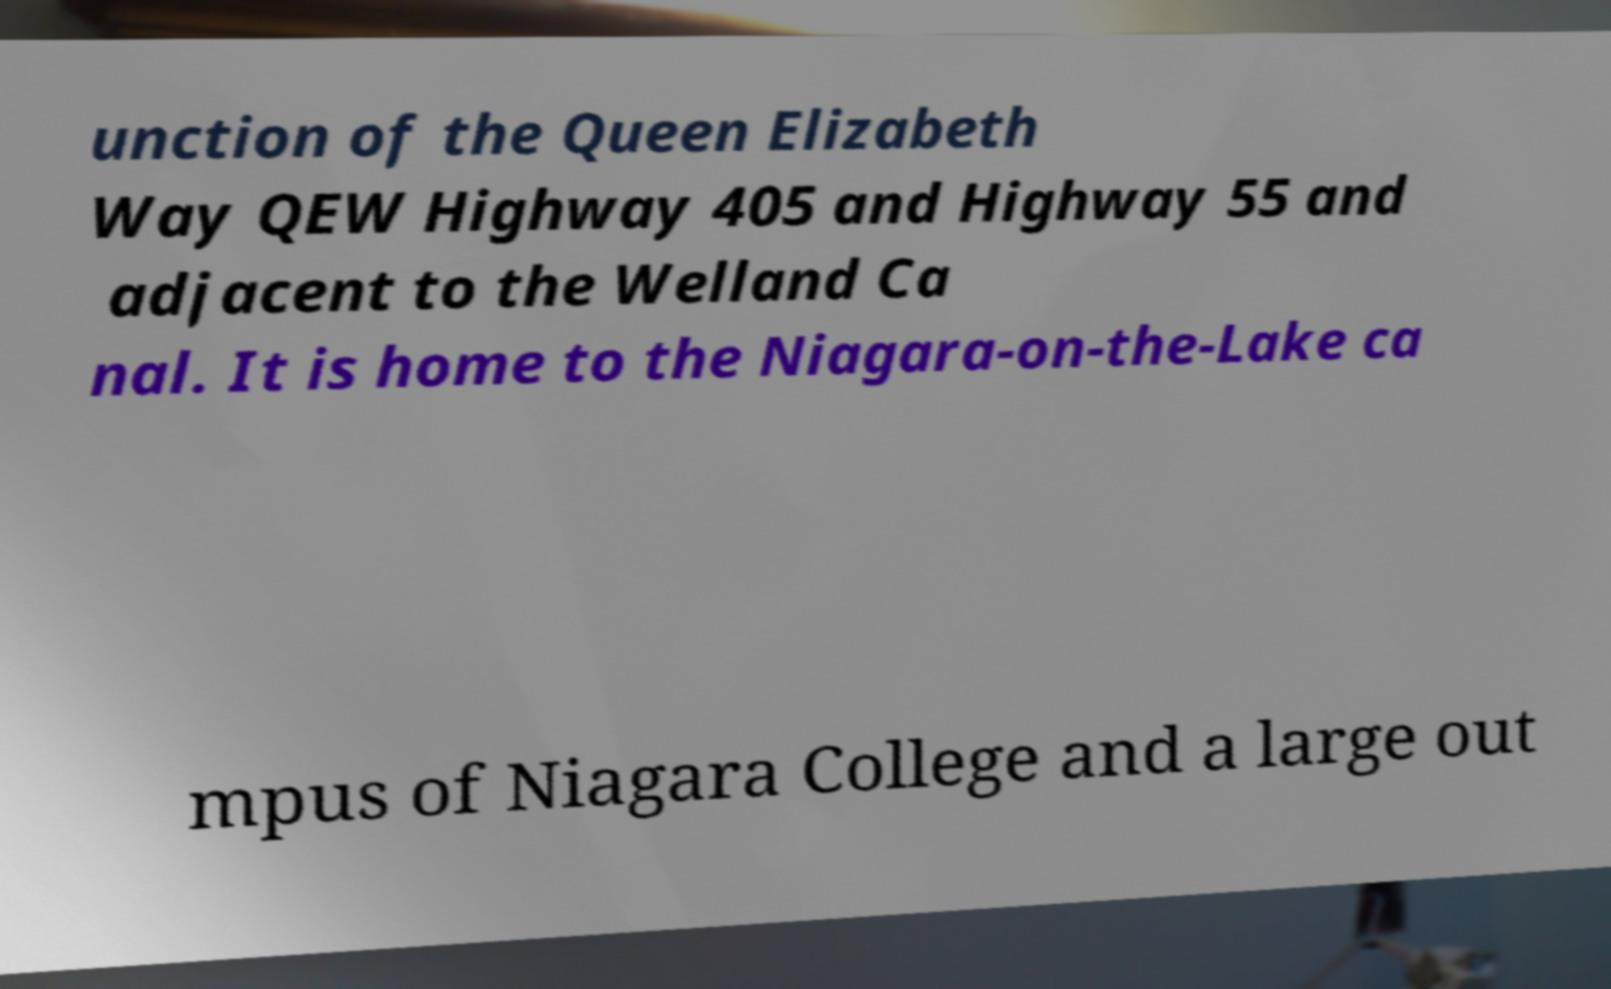Could you extract and type out the text from this image? unction of the Queen Elizabeth Way QEW Highway 405 and Highway 55 and adjacent to the Welland Ca nal. It is home to the Niagara-on-the-Lake ca mpus of Niagara College and a large out 